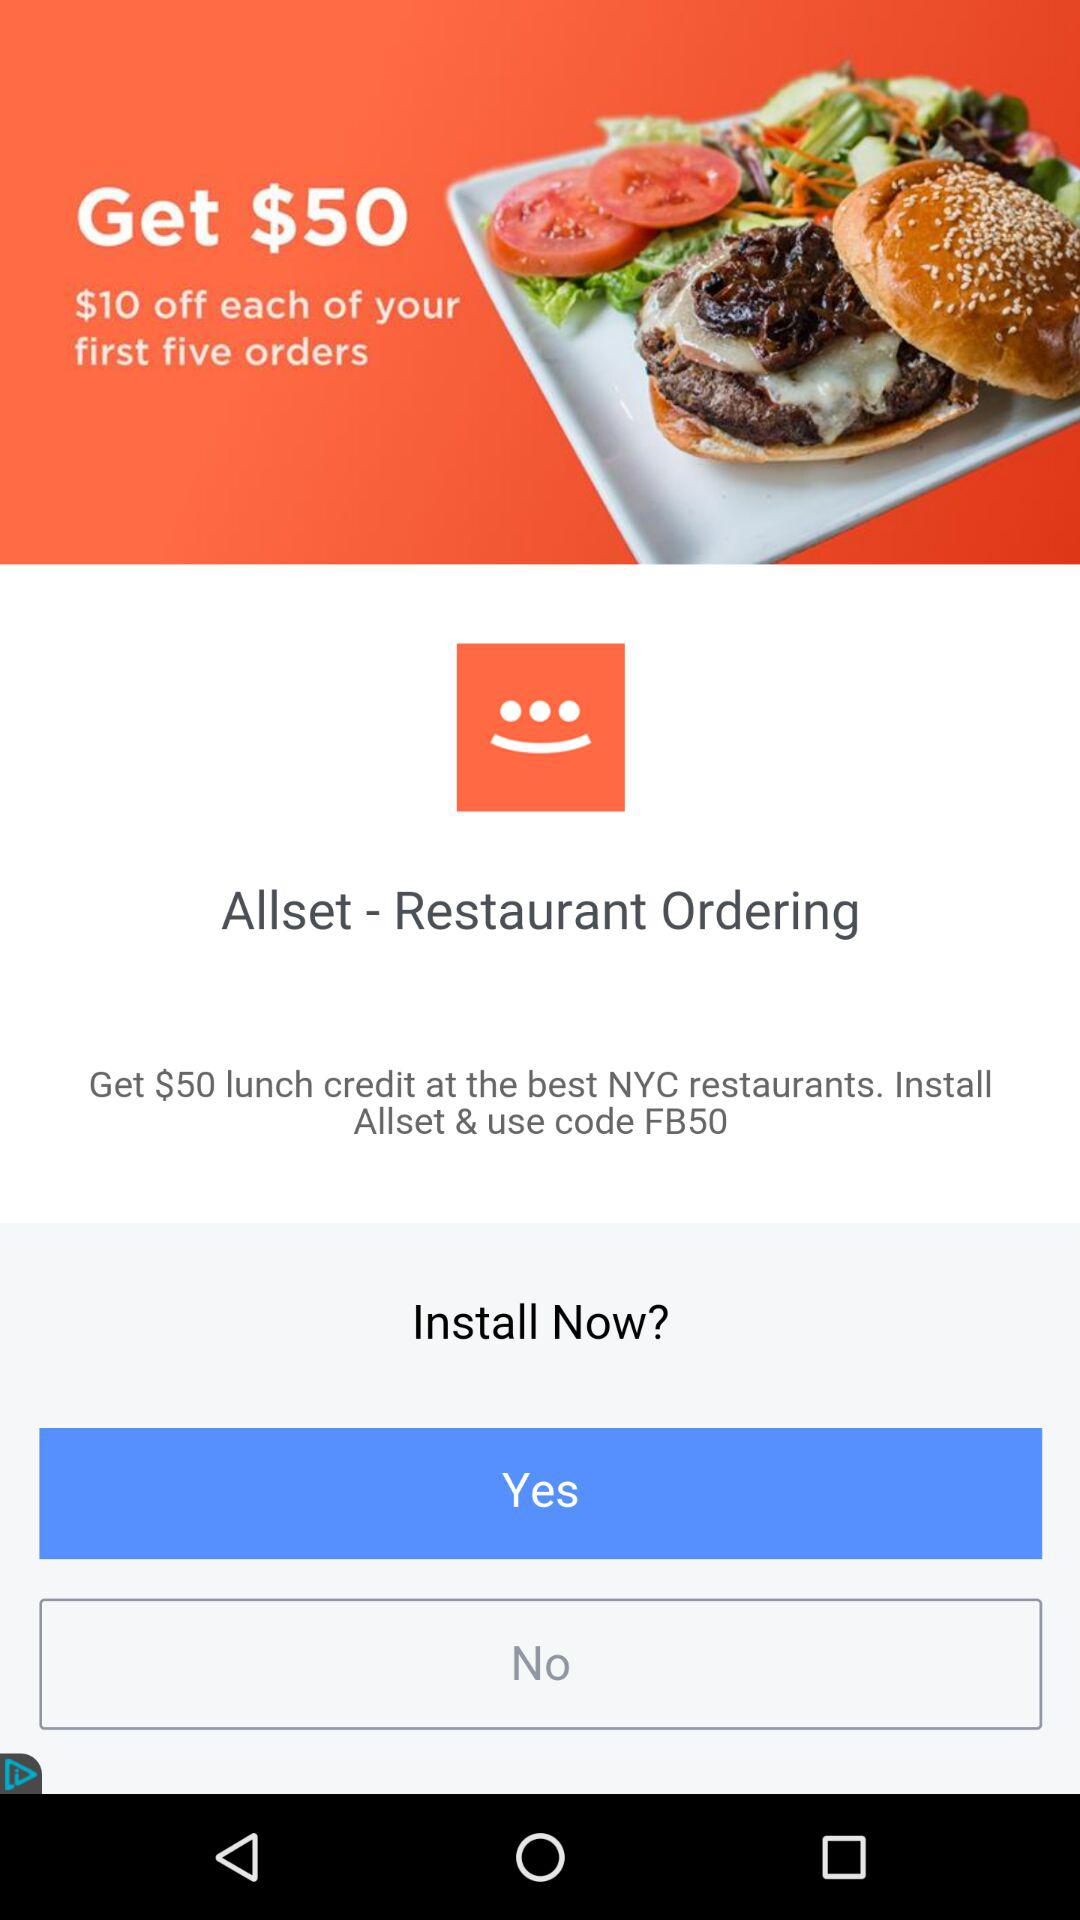How many dollars of credit do you get with the code FB50?
Answer the question using a single word or phrase. $50 